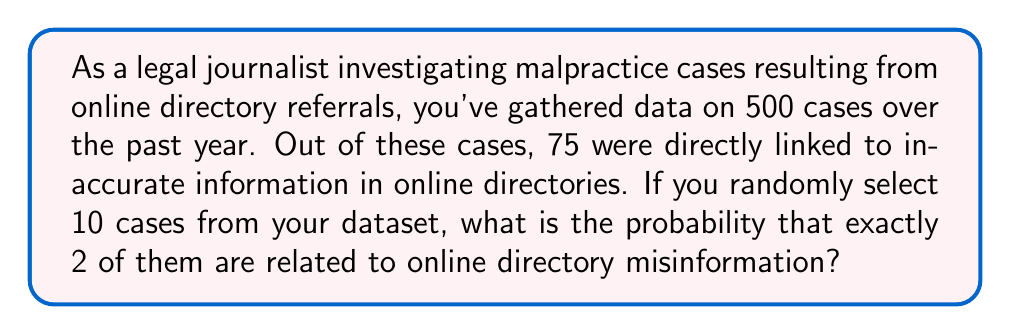Solve this math problem. To solve this problem, we need to use the binomial probability formula, as we're dealing with a fixed number of independent trials (selecting 10 cases) with two possible outcomes for each trial (related or not related to online directory misinformation).

Let's define our variables:
$n = 10$ (number of cases selected)
$k = 2$ (number of successes we're looking for)
$p = 75/500 = 0.15$ (probability of a single case being related to online directory misinformation)
$q = 1 - p = 0.85$ (probability of a single case not being related to online directory misinformation)

The binomial probability formula is:

$$P(X = k) = \binom{n}{k} p^k q^{n-k}$$

Where $\binom{n}{k}$ is the binomial coefficient, calculated as:

$$\binom{n}{k} = \frac{n!}{k!(n-k)!}$$

Let's calculate step by step:

1) First, calculate the binomial coefficient:
   $$\binom{10}{2} = \frac{10!}{2!(10-2)!} = \frac{10!}{2!8!} = 45$$

2) Now, let's plug everything into the binomial probability formula:
   $$P(X = 2) = 45 \cdot (0.15)^2 \cdot (0.85)^{10-2}$$

3) Simplify:
   $$P(X = 2) = 45 \cdot (0.0225) \cdot (0.3138) \approx 0.3177$$

Therefore, the probability of exactly 2 out of 10 randomly selected cases being related to online directory misinformation is approximately 0.3177 or 31.77%.
Answer: $0.3177$ or $31.77\%$ 